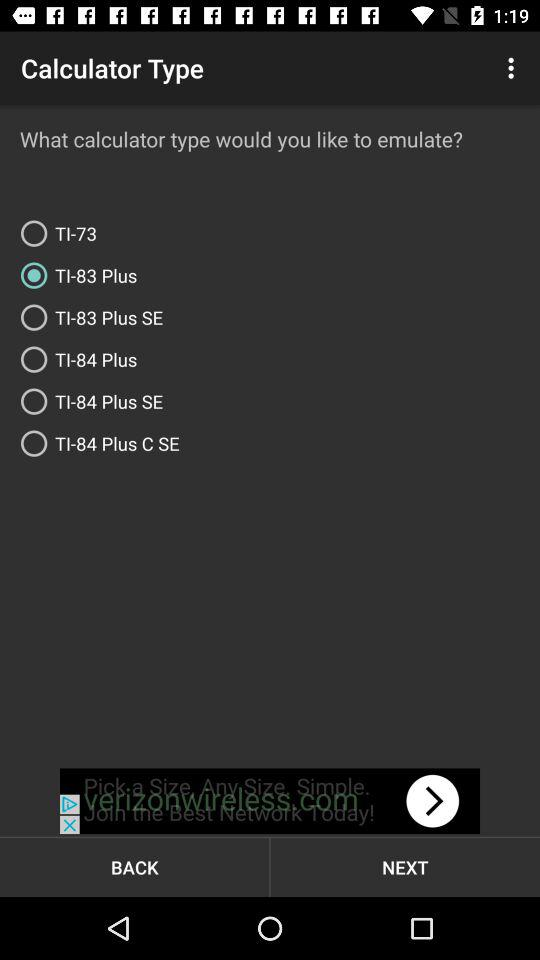Which are the different options? The different options are "I already have a ROM file" and "Help me create a ROM using open source software". 